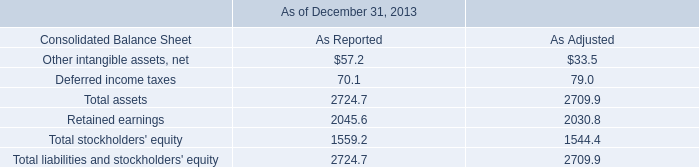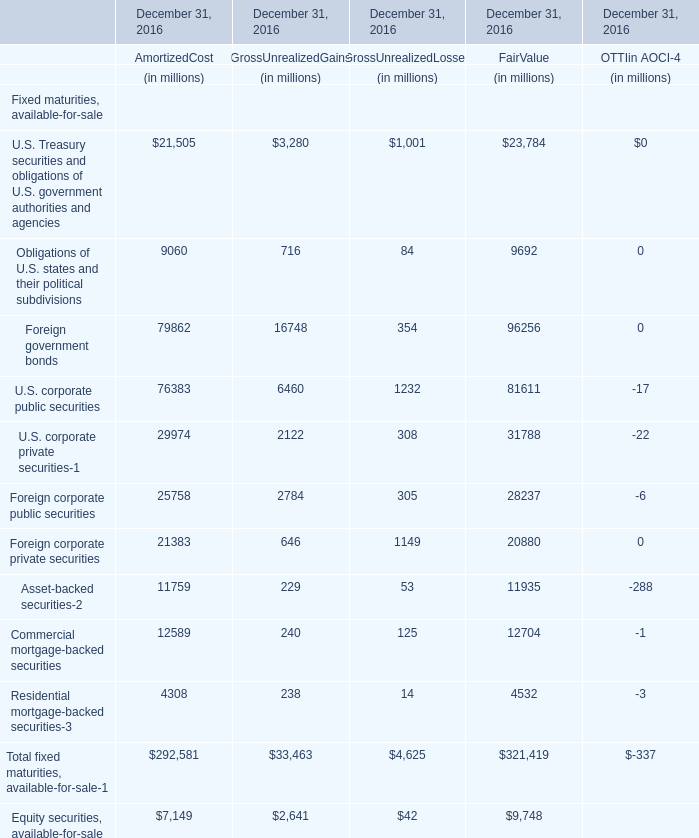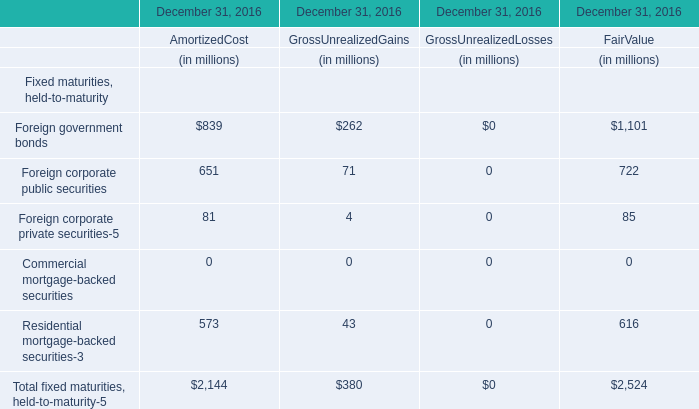In what sections is U.S. Treasury securities and obligations of U.S. government authorities and agencies greater than 1? 
Answer: AmortizedCost GrossUnrealizedGains GrossUnrealizedLosses FairValue. 